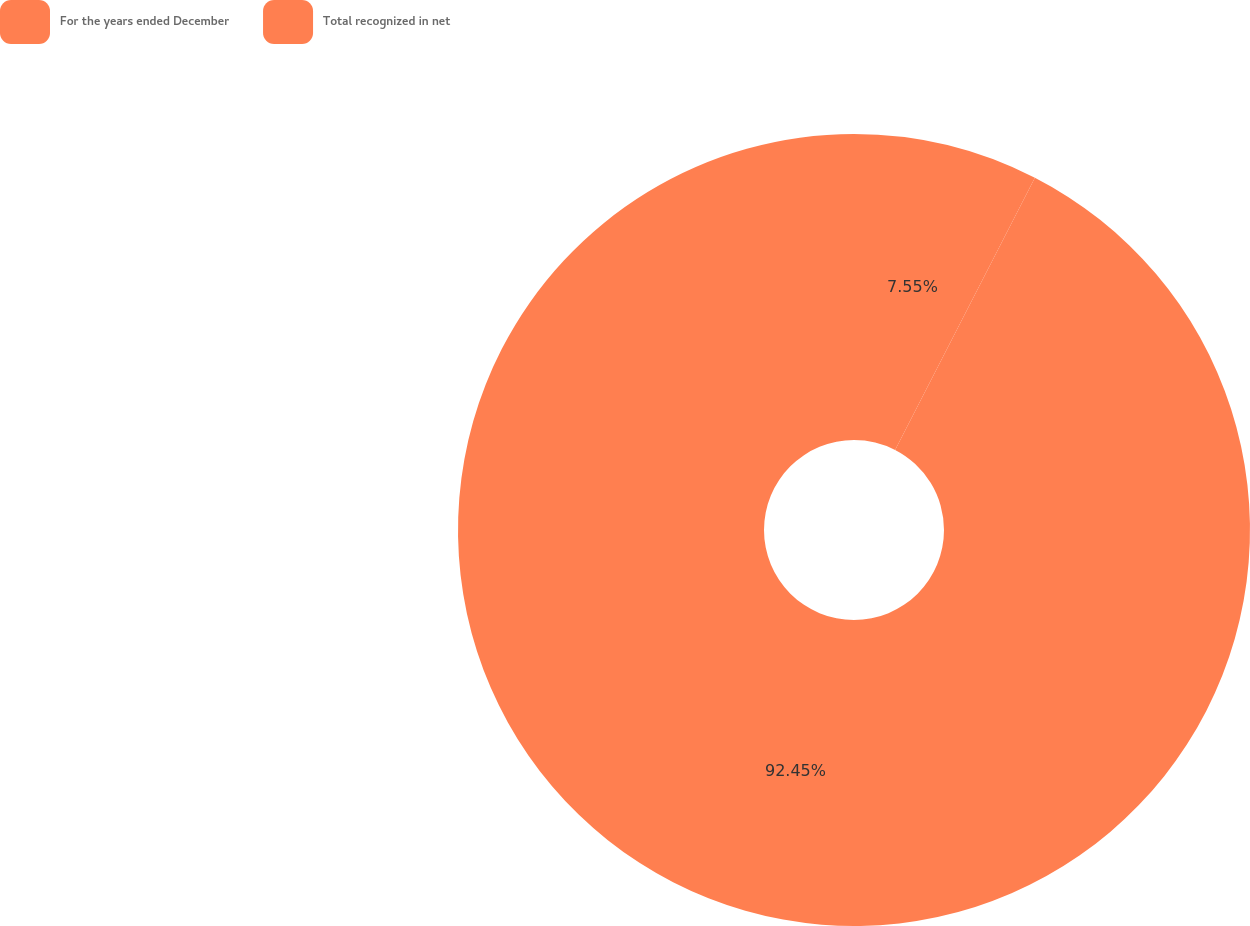Convert chart to OTSL. <chart><loc_0><loc_0><loc_500><loc_500><pie_chart><fcel>For the years ended December<fcel>Total recognized in net<nl><fcel>7.55%<fcel>92.45%<nl></chart> 